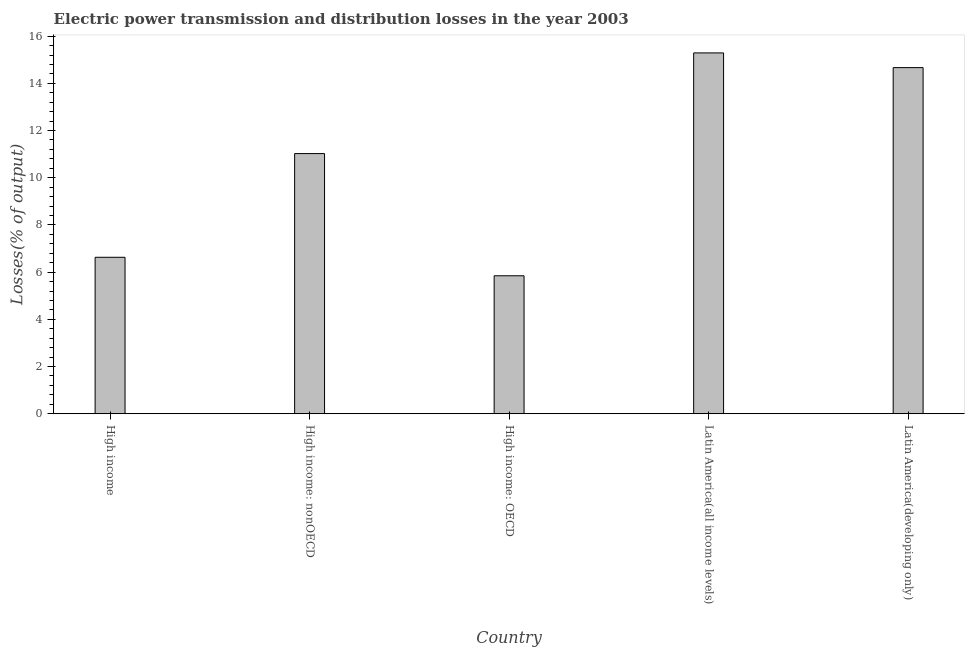Does the graph contain any zero values?
Make the answer very short. No. Does the graph contain grids?
Offer a terse response. No. What is the title of the graph?
Keep it short and to the point. Electric power transmission and distribution losses in the year 2003. What is the label or title of the X-axis?
Your answer should be very brief. Country. What is the label or title of the Y-axis?
Provide a succinct answer. Losses(% of output). What is the electric power transmission and distribution losses in High income: OECD?
Provide a succinct answer. 5.85. Across all countries, what is the maximum electric power transmission and distribution losses?
Offer a very short reply. 15.29. Across all countries, what is the minimum electric power transmission and distribution losses?
Your answer should be very brief. 5.85. In which country was the electric power transmission and distribution losses maximum?
Your answer should be very brief. Latin America(all income levels). In which country was the electric power transmission and distribution losses minimum?
Offer a terse response. High income: OECD. What is the sum of the electric power transmission and distribution losses?
Make the answer very short. 53.45. What is the difference between the electric power transmission and distribution losses in High income and High income: OECD?
Provide a succinct answer. 0.78. What is the average electric power transmission and distribution losses per country?
Your answer should be compact. 10.69. What is the median electric power transmission and distribution losses?
Your answer should be compact. 11.02. In how many countries, is the electric power transmission and distribution losses greater than 4 %?
Make the answer very short. 5. What is the ratio of the electric power transmission and distribution losses in High income to that in Latin America(developing only)?
Give a very brief answer. 0.45. Is the electric power transmission and distribution losses in Latin America(all income levels) less than that in Latin America(developing only)?
Your answer should be compact. No. Is the difference between the electric power transmission and distribution losses in High income: OECD and Latin America(all income levels) greater than the difference between any two countries?
Keep it short and to the point. Yes. What is the difference between the highest and the second highest electric power transmission and distribution losses?
Keep it short and to the point. 0.62. Is the sum of the electric power transmission and distribution losses in High income and High income: OECD greater than the maximum electric power transmission and distribution losses across all countries?
Your answer should be compact. No. What is the difference between the highest and the lowest electric power transmission and distribution losses?
Provide a short and direct response. 9.44. How many bars are there?
Offer a terse response. 5. Are all the bars in the graph horizontal?
Ensure brevity in your answer.  No. What is the difference between two consecutive major ticks on the Y-axis?
Provide a short and direct response. 2. Are the values on the major ticks of Y-axis written in scientific E-notation?
Your answer should be very brief. No. What is the Losses(% of output) in High income?
Make the answer very short. 6.63. What is the Losses(% of output) in High income: nonOECD?
Give a very brief answer. 11.02. What is the Losses(% of output) in High income: OECD?
Offer a terse response. 5.85. What is the Losses(% of output) of Latin America(all income levels)?
Ensure brevity in your answer.  15.29. What is the Losses(% of output) in Latin America(developing only)?
Your answer should be compact. 14.67. What is the difference between the Losses(% of output) in High income and High income: nonOECD?
Offer a terse response. -4.39. What is the difference between the Losses(% of output) in High income and High income: OECD?
Provide a succinct answer. 0.78. What is the difference between the Losses(% of output) in High income and Latin America(all income levels)?
Offer a terse response. -8.66. What is the difference between the Losses(% of output) in High income and Latin America(developing only)?
Your answer should be compact. -8.04. What is the difference between the Losses(% of output) in High income: nonOECD and High income: OECD?
Your answer should be compact. 5.18. What is the difference between the Losses(% of output) in High income: nonOECD and Latin America(all income levels)?
Your answer should be very brief. -4.27. What is the difference between the Losses(% of output) in High income: nonOECD and Latin America(developing only)?
Provide a succinct answer. -3.64. What is the difference between the Losses(% of output) in High income: OECD and Latin America(all income levels)?
Make the answer very short. -9.44. What is the difference between the Losses(% of output) in High income: OECD and Latin America(developing only)?
Offer a terse response. -8.82. What is the difference between the Losses(% of output) in Latin America(all income levels) and Latin America(developing only)?
Ensure brevity in your answer.  0.62. What is the ratio of the Losses(% of output) in High income to that in High income: nonOECD?
Offer a terse response. 0.6. What is the ratio of the Losses(% of output) in High income to that in High income: OECD?
Your response must be concise. 1.13. What is the ratio of the Losses(% of output) in High income to that in Latin America(all income levels)?
Your answer should be compact. 0.43. What is the ratio of the Losses(% of output) in High income to that in Latin America(developing only)?
Give a very brief answer. 0.45. What is the ratio of the Losses(% of output) in High income: nonOECD to that in High income: OECD?
Your response must be concise. 1.89. What is the ratio of the Losses(% of output) in High income: nonOECD to that in Latin America(all income levels)?
Keep it short and to the point. 0.72. What is the ratio of the Losses(% of output) in High income: nonOECD to that in Latin America(developing only)?
Provide a short and direct response. 0.75. What is the ratio of the Losses(% of output) in High income: OECD to that in Latin America(all income levels)?
Offer a very short reply. 0.38. What is the ratio of the Losses(% of output) in High income: OECD to that in Latin America(developing only)?
Make the answer very short. 0.4. What is the ratio of the Losses(% of output) in Latin America(all income levels) to that in Latin America(developing only)?
Offer a terse response. 1.04. 